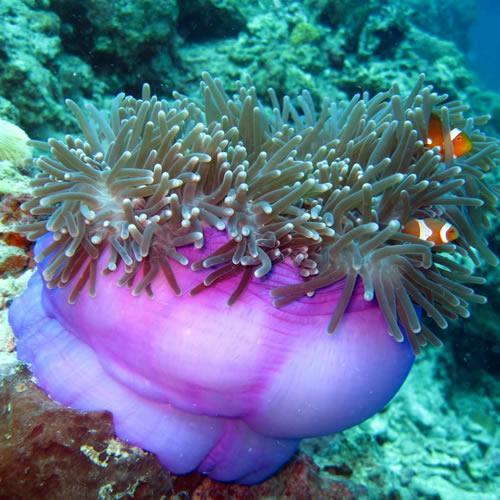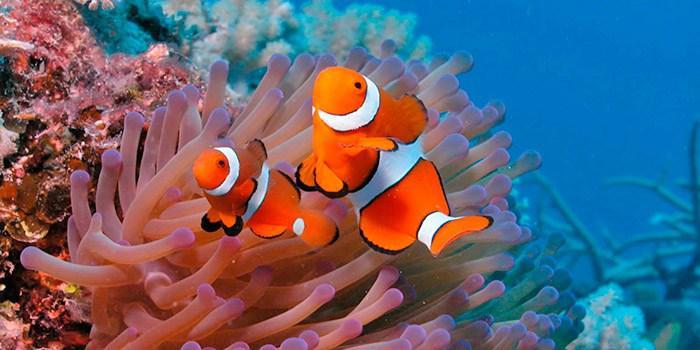The first image is the image on the left, the second image is the image on the right. Given the left and right images, does the statement "There are three clownfish next to a sea anemone in the right image" hold true? Answer yes or no. No. The first image is the image on the left, the second image is the image on the right. Given the left and right images, does the statement "The left image features an anemone with a wide violet-colored stalk, and the right image shows multiple leftward-turned clownfish swimming among anemone tendrils." hold true? Answer yes or no. Yes. 